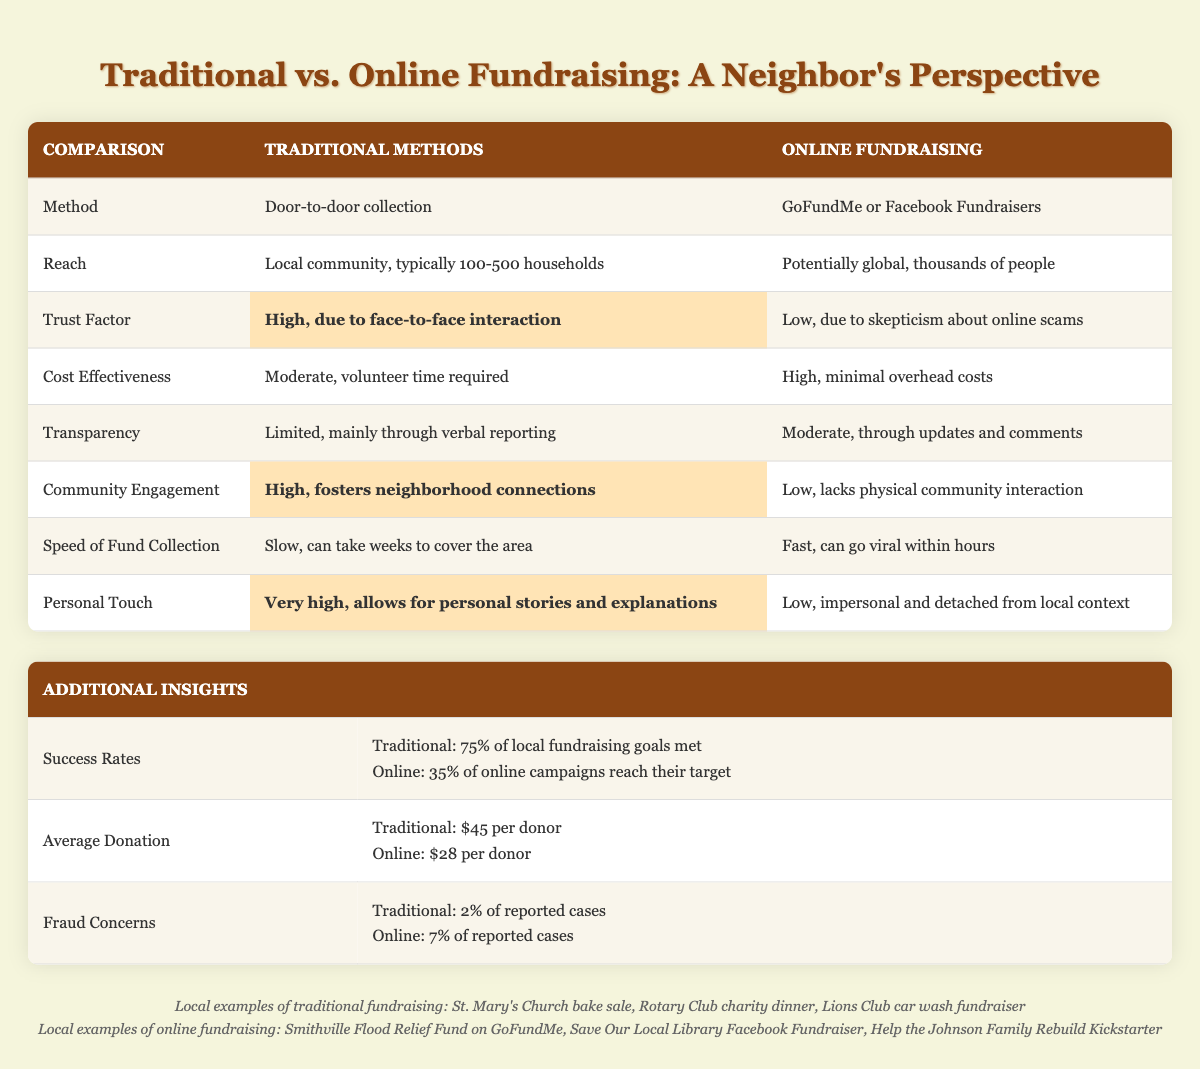What is the average donation amount for traditional fundraising methods? The table indicates that the average donation for traditional methods is $45 per donor. This value is found directly in the "Average Donation" row under the "Traditional" column.
Answer: $45 What is the reach of online fundraising methods? The table shows that the reach of online fundraising methods is described as "Potentially global, thousands of people." This fact is stated directly in the "Reach" row under the "Online Fundraising" column.
Answer: Potentially global, thousands of people What percentage of online campaigns reach their fundraising targets? According to the table, only 35% of online campaigns reach their target, while traditional methods achieve a success rate of 75% as noted in the "Success Rates" section.
Answer: 35% Is the trust factor higher for traditional fundraising compared to online fundraising? Yes, the table shows that the trust factor for traditional fundraising methods is "High, due to face-to-face interaction," while the trust factor for online fundraising is "Low, due to skepticism about online scams," indicating a clear difference in trust levels.
Answer: Yes How do traditional fundraising methods compare to online methods in terms of community engagement? The table states that traditional methods have a "High" level of community engagement, while online fundraising has a "Low" level. This comparison indicates that traditional methods are much better at fostering neighborhood connections.
Answer: Traditional methods are better What is the difference in average donation amounts between traditional and online fundraising methods? The average donation for traditional methods is $45, and for online methods, it is $28. To find the difference, subtract the online amount from the traditional amount: $45 - $28 = $17.
Answer: $17 Which fundraising method has lower fraud concerns based on the table? Traditional fundraising has a fraud concern rate of 2%, while online fundraising has a higher rate of 7%. Therefore, traditional methods have lower fraud concerns.
Answer: Traditional fundraising Which method collects funds faster, traditional or online, and by how much? The table indicates that traditional methods are "Slow" and can take weeks for collection, while online methods are "Fast," potentially going viral within hours. The exact difference in terms of time is not specified, but the qualitative descriptions clearly show online methods are much faster.
Answer: Online fundraising is faster 